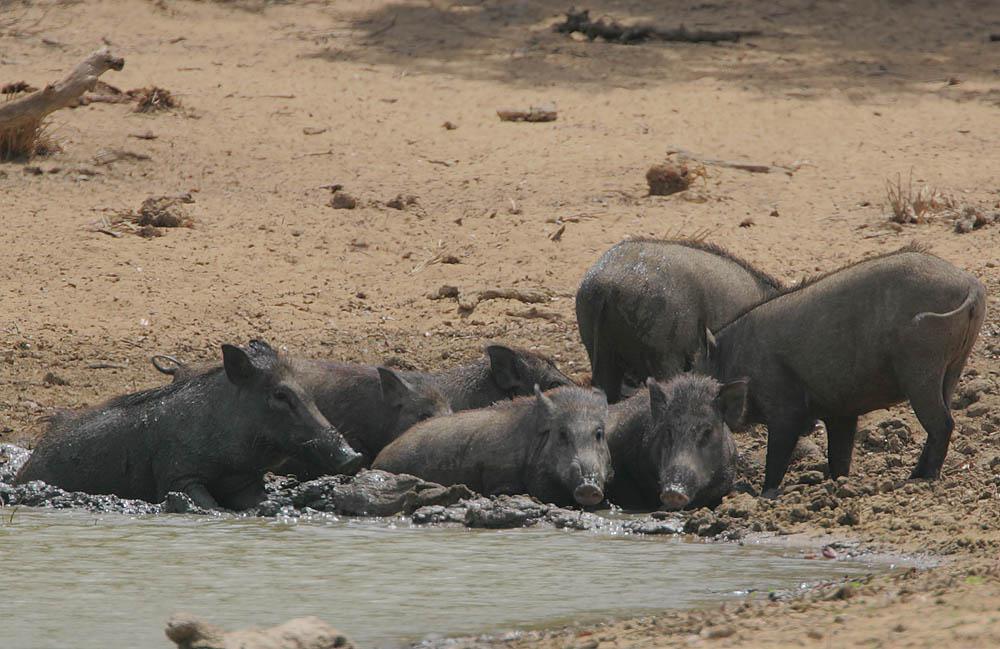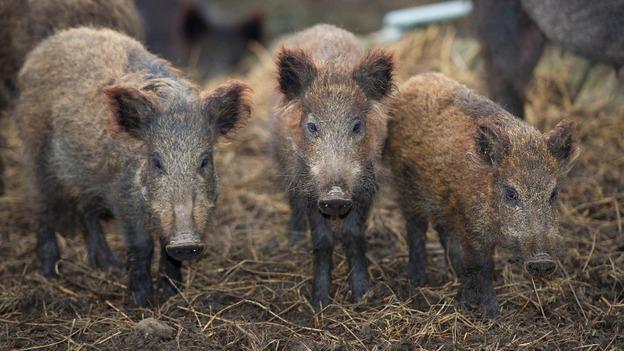The first image is the image on the left, the second image is the image on the right. Considering the images on both sides, is "At least one wild animal is wallowing in the mud." valid? Answer yes or no. Yes. The first image is the image on the left, the second image is the image on the right. Given the left and right images, does the statement "An image shows at least one wild pig in the mud." hold true? Answer yes or no. Yes. 